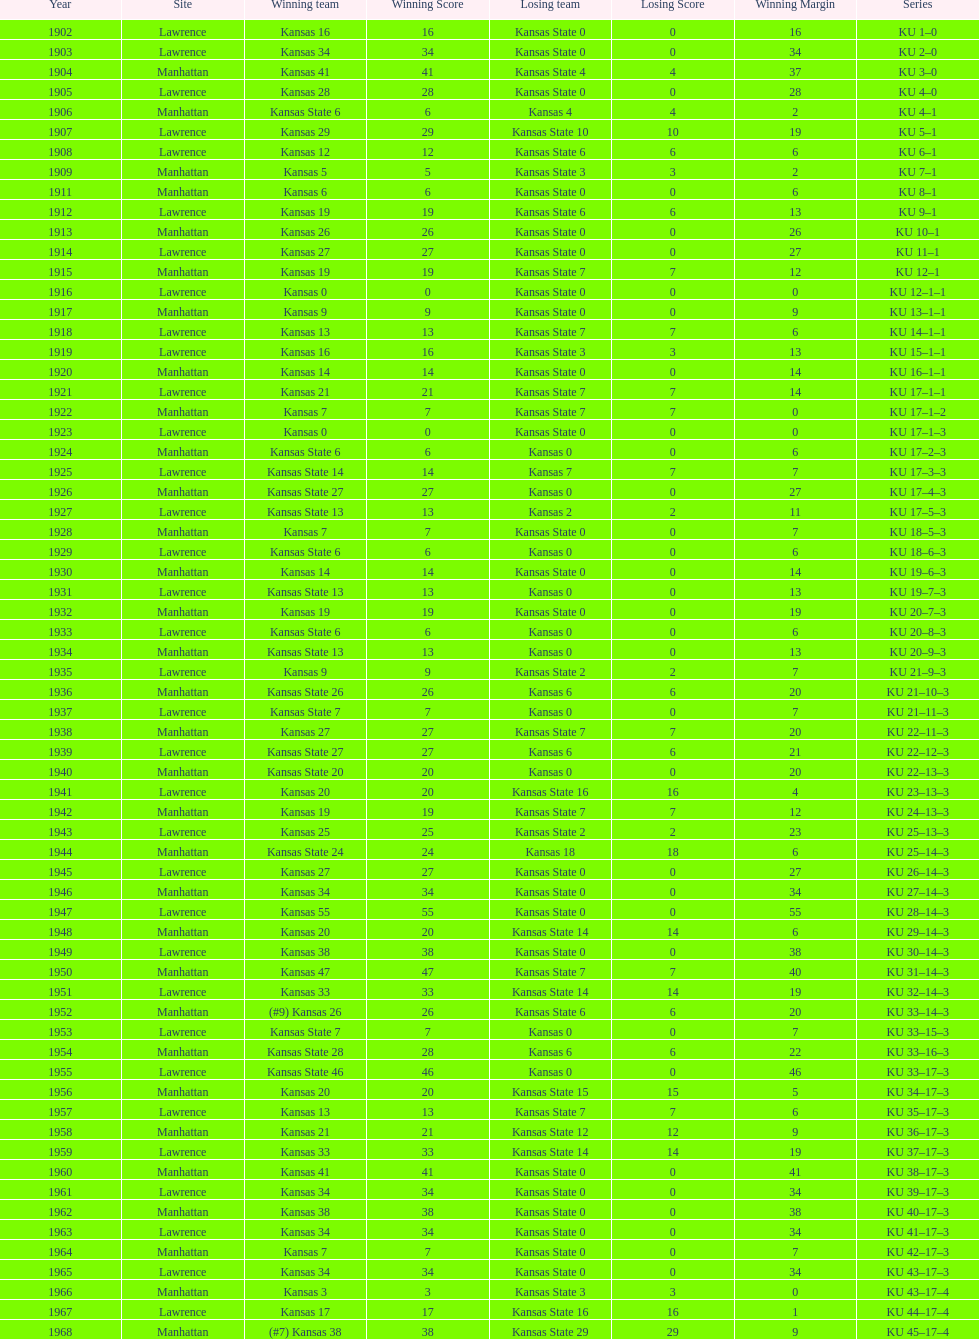When was the last time kansas state lost with 0 points in manhattan? 1964. I'm looking to parse the entire table for insights. Could you assist me with that? {'header': ['Year', 'Site', 'Winning team', 'Winning Score', 'Losing team', 'Losing Score', 'Winning Margin', 'Series'], 'rows': [['1902', 'Lawrence', 'Kansas 16', '16', 'Kansas State 0', '0', '16', 'KU 1–0'], ['1903', 'Lawrence', 'Kansas 34', '34', 'Kansas State 0', '0', '34', 'KU 2–0'], ['1904', 'Manhattan', 'Kansas 41', '41', 'Kansas State 4', '4', '37', 'KU 3–0'], ['1905', 'Lawrence', 'Kansas 28', '28', 'Kansas State 0', '0', '28', 'KU 4–0'], ['1906', 'Manhattan', 'Kansas State 6', '6', 'Kansas 4', '4', '2', 'KU 4–1'], ['1907', 'Lawrence', 'Kansas 29', '29', 'Kansas State 10', '10', '19', 'KU 5–1'], ['1908', 'Lawrence', 'Kansas 12', '12', 'Kansas State 6', '6', '6', 'KU 6–1'], ['1909', 'Manhattan', 'Kansas 5', '5', 'Kansas State 3', '3', '2', 'KU 7–1'], ['1911', 'Manhattan', 'Kansas 6', '6', 'Kansas State 0', '0', '6', 'KU 8–1'], ['1912', 'Lawrence', 'Kansas 19', '19', 'Kansas State 6', '6', '13', 'KU 9–1'], ['1913', 'Manhattan', 'Kansas 26', '26', 'Kansas State 0', '0', '26', 'KU 10–1'], ['1914', 'Lawrence', 'Kansas 27', '27', 'Kansas State 0', '0', '27', 'KU 11–1'], ['1915', 'Manhattan', 'Kansas 19', '19', 'Kansas State 7', '7', '12', 'KU 12–1'], ['1916', 'Lawrence', 'Kansas 0', '0', 'Kansas State 0', '0', '0', 'KU 12–1–1'], ['1917', 'Manhattan', 'Kansas 9', '9', 'Kansas State 0', '0', '9', 'KU 13–1–1'], ['1918', 'Lawrence', 'Kansas 13', '13', 'Kansas State 7', '7', '6', 'KU 14–1–1'], ['1919', 'Lawrence', 'Kansas 16', '16', 'Kansas State 3', '3', '13', 'KU 15–1–1'], ['1920', 'Manhattan', 'Kansas 14', '14', 'Kansas State 0', '0', '14', 'KU 16–1–1'], ['1921', 'Lawrence', 'Kansas 21', '21', 'Kansas State 7', '7', '14', 'KU 17–1–1'], ['1922', 'Manhattan', 'Kansas 7', '7', 'Kansas State 7', '7', '0', 'KU 17–1–2'], ['1923', 'Lawrence', 'Kansas 0', '0', 'Kansas State 0', '0', '0', 'KU 17–1–3'], ['1924', 'Manhattan', 'Kansas State 6', '6', 'Kansas 0', '0', '6', 'KU 17–2–3'], ['1925', 'Lawrence', 'Kansas State 14', '14', 'Kansas 7', '7', '7', 'KU 17–3–3'], ['1926', 'Manhattan', 'Kansas State 27', '27', 'Kansas 0', '0', '27', 'KU 17–4–3'], ['1927', 'Lawrence', 'Kansas State 13', '13', 'Kansas 2', '2', '11', 'KU 17–5–3'], ['1928', 'Manhattan', 'Kansas 7', '7', 'Kansas State 0', '0', '7', 'KU 18–5–3'], ['1929', 'Lawrence', 'Kansas State 6', '6', 'Kansas 0', '0', '6', 'KU 18–6–3'], ['1930', 'Manhattan', 'Kansas 14', '14', 'Kansas State 0', '0', '14', 'KU 19–6–3'], ['1931', 'Lawrence', 'Kansas State 13', '13', 'Kansas 0', '0', '13', 'KU 19–7–3'], ['1932', 'Manhattan', 'Kansas 19', '19', 'Kansas State 0', '0', '19', 'KU 20–7–3'], ['1933', 'Lawrence', 'Kansas State 6', '6', 'Kansas 0', '0', '6', 'KU 20–8–3'], ['1934', 'Manhattan', 'Kansas State 13', '13', 'Kansas 0', '0', '13', 'KU 20–9–3'], ['1935', 'Lawrence', 'Kansas 9', '9', 'Kansas State 2', '2', '7', 'KU 21–9–3'], ['1936', 'Manhattan', 'Kansas State 26', '26', 'Kansas 6', '6', '20', 'KU 21–10–3'], ['1937', 'Lawrence', 'Kansas State 7', '7', 'Kansas 0', '0', '7', 'KU 21–11–3'], ['1938', 'Manhattan', 'Kansas 27', '27', 'Kansas State 7', '7', '20', 'KU 22–11–3'], ['1939', 'Lawrence', 'Kansas State 27', '27', 'Kansas 6', '6', '21', 'KU 22–12–3'], ['1940', 'Manhattan', 'Kansas State 20', '20', 'Kansas 0', '0', '20', 'KU 22–13–3'], ['1941', 'Lawrence', 'Kansas 20', '20', 'Kansas State 16', '16', '4', 'KU 23–13–3'], ['1942', 'Manhattan', 'Kansas 19', '19', 'Kansas State 7', '7', '12', 'KU 24–13–3'], ['1943', 'Lawrence', 'Kansas 25', '25', 'Kansas State 2', '2', '23', 'KU 25–13–3'], ['1944', 'Manhattan', 'Kansas State 24', '24', 'Kansas 18', '18', '6', 'KU 25–14–3'], ['1945', 'Lawrence', 'Kansas 27', '27', 'Kansas State 0', '0', '27', 'KU 26–14–3'], ['1946', 'Manhattan', 'Kansas 34', '34', 'Kansas State 0', '0', '34', 'KU 27–14–3'], ['1947', 'Lawrence', 'Kansas 55', '55', 'Kansas State 0', '0', '55', 'KU 28–14–3'], ['1948', 'Manhattan', 'Kansas 20', '20', 'Kansas State 14', '14', '6', 'KU 29–14–3'], ['1949', 'Lawrence', 'Kansas 38', '38', 'Kansas State 0', '0', '38', 'KU 30–14–3'], ['1950', 'Manhattan', 'Kansas 47', '47', 'Kansas State 7', '7', '40', 'KU 31–14–3'], ['1951', 'Lawrence', 'Kansas 33', '33', 'Kansas State 14', '14', '19', 'KU 32–14–3'], ['1952', 'Manhattan', '(#9) Kansas 26', '26', 'Kansas State 6', '6', '20', 'KU 33–14–3'], ['1953', 'Lawrence', 'Kansas State 7', '7', 'Kansas 0', '0', '7', 'KU 33–15–3'], ['1954', 'Manhattan', 'Kansas State 28', '28', 'Kansas 6', '6', '22', 'KU 33–16–3'], ['1955', 'Lawrence', 'Kansas State 46', '46', 'Kansas 0', '0', '46', 'KU 33–17–3'], ['1956', 'Manhattan', 'Kansas 20', '20', 'Kansas State 15', '15', '5', 'KU 34–17–3'], ['1957', 'Lawrence', 'Kansas 13', '13', 'Kansas State 7', '7', '6', 'KU 35–17–3'], ['1958', 'Manhattan', 'Kansas 21', '21', 'Kansas State 12', '12', '9', 'KU 36–17–3'], ['1959', 'Lawrence', 'Kansas 33', '33', 'Kansas State 14', '14', '19', 'KU 37–17–3'], ['1960', 'Manhattan', 'Kansas 41', '41', 'Kansas State 0', '0', '41', 'KU 38–17–3'], ['1961', 'Lawrence', 'Kansas 34', '34', 'Kansas State 0', '0', '34', 'KU 39–17–3'], ['1962', 'Manhattan', 'Kansas 38', '38', 'Kansas State 0', '0', '38', 'KU 40–17–3'], ['1963', 'Lawrence', 'Kansas 34', '34', 'Kansas State 0', '0', '34', 'KU 41–17–3'], ['1964', 'Manhattan', 'Kansas 7', '7', 'Kansas State 0', '0', '7', 'KU 42–17–3'], ['1965', 'Lawrence', 'Kansas 34', '34', 'Kansas State 0', '0', '34', 'KU 43–17–3'], ['1966', 'Manhattan', 'Kansas 3', '3', 'Kansas State 3', '3', '0', 'KU 43–17–4'], ['1967', 'Lawrence', 'Kansas 17', '17', 'Kansas State 16', '16', '1', 'KU 44–17–4'], ['1968', 'Manhattan', '(#7) Kansas 38', '38', 'Kansas State 29', '29', '9', 'KU 45–17–4']]} 